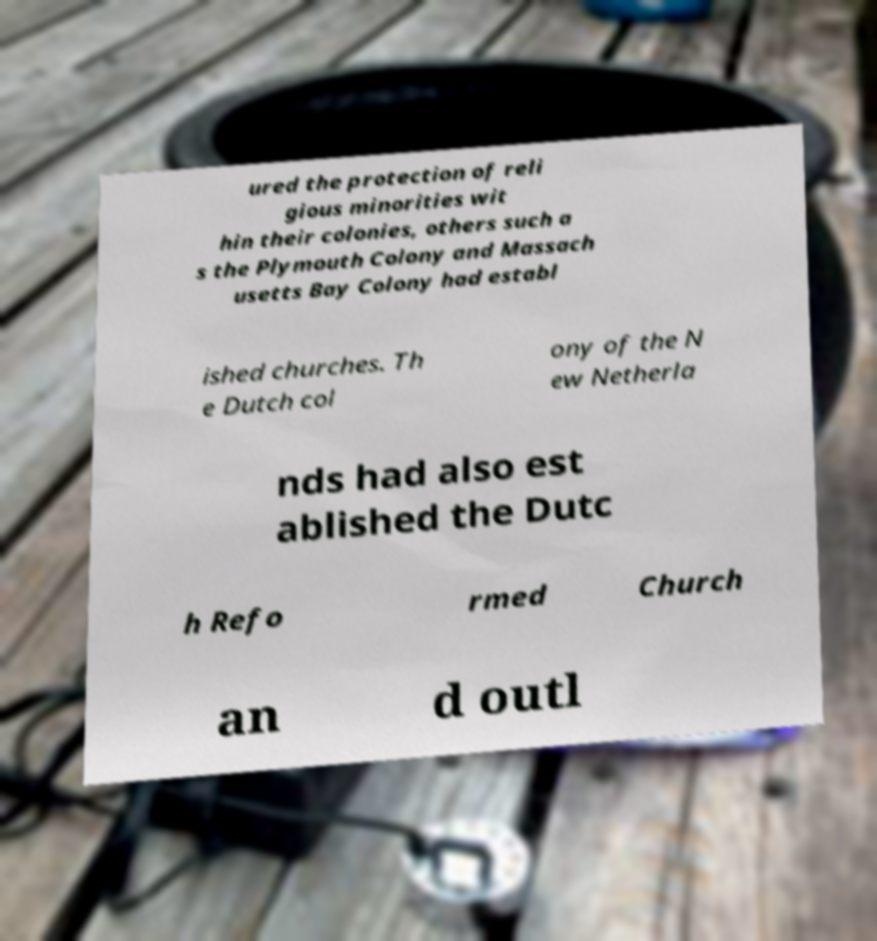For documentation purposes, I need the text within this image transcribed. Could you provide that? ured the protection of reli gious minorities wit hin their colonies, others such a s the Plymouth Colony and Massach usetts Bay Colony had establ ished churches. Th e Dutch col ony of the N ew Netherla nds had also est ablished the Dutc h Refo rmed Church an d outl 